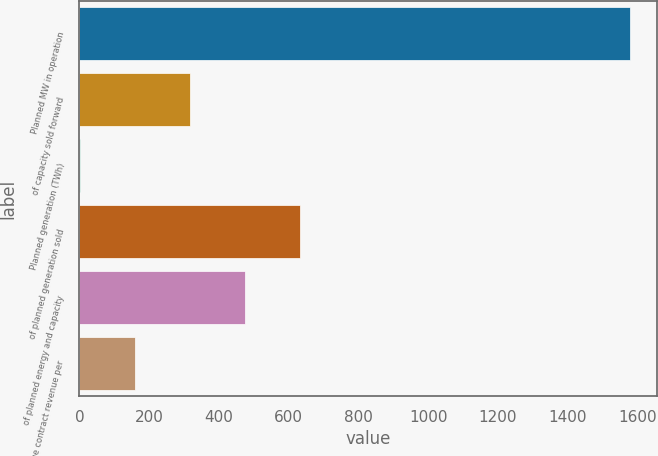Convert chart to OTSL. <chart><loc_0><loc_0><loc_500><loc_500><bar_chart><fcel>Planned MW in operation<fcel>of capacity sold forward<fcel>Planned generation (TWh)<fcel>of planned generation sold<fcel>of planned energy and capacity<fcel>Average contract revenue per<nl><fcel>1578<fcel>318<fcel>3<fcel>633<fcel>475.5<fcel>160.5<nl></chart> 